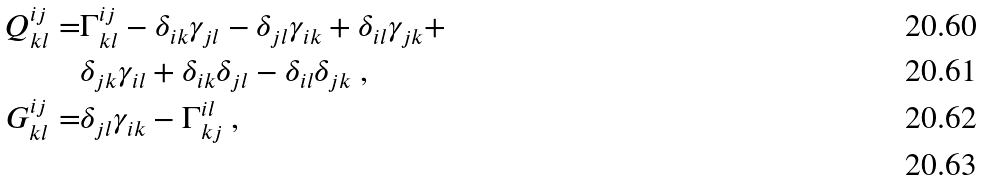Convert formula to latex. <formula><loc_0><loc_0><loc_500><loc_500>Q ^ { i j } _ { k l } = & \Gamma ^ { i j } _ { k l } - \delta _ { i k } \gamma _ { j l } - \delta _ { j l } \gamma _ { i k } + \delta _ { i l } \gamma _ { j k } + \\ & \delta _ { j k } \gamma _ { i l } + \delta _ { i k } \delta _ { j l } - \delta _ { i l } \delta _ { j k } \ , \\ G ^ { i j } _ { k l } = & \delta _ { j l } \gamma _ { i k } - \Gamma ^ { i l } _ { k j } \ , \\</formula> 